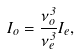<formula> <loc_0><loc_0><loc_500><loc_500>I _ { o } = \frac { \nu _ { o } ^ { 3 } } { \nu _ { e } ^ { 3 } } I _ { e } ,</formula> 